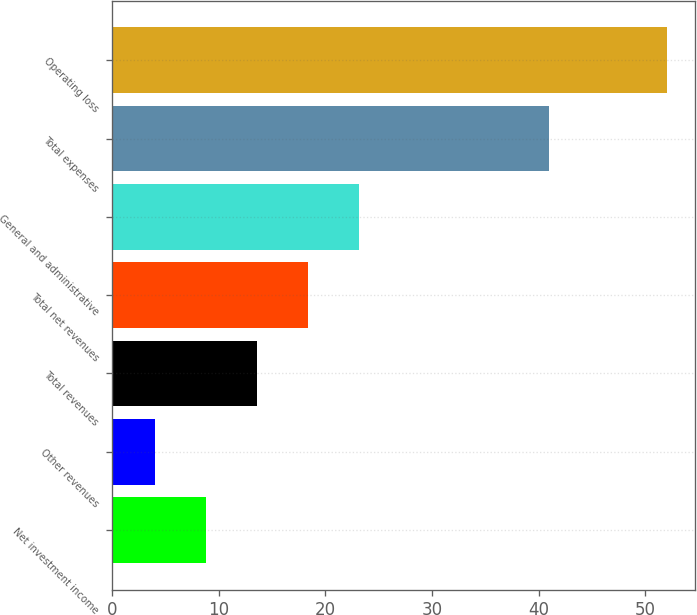Convert chart. <chart><loc_0><loc_0><loc_500><loc_500><bar_chart><fcel>Net investment income<fcel>Other revenues<fcel>Total revenues<fcel>Total net revenues<fcel>General and administrative<fcel>Total expenses<fcel>Operating loss<nl><fcel>8.8<fcel>4<fcel>13.6<fcel>18.4<fcel>23.2<fcel>41<fcel>52<nl></chart> 